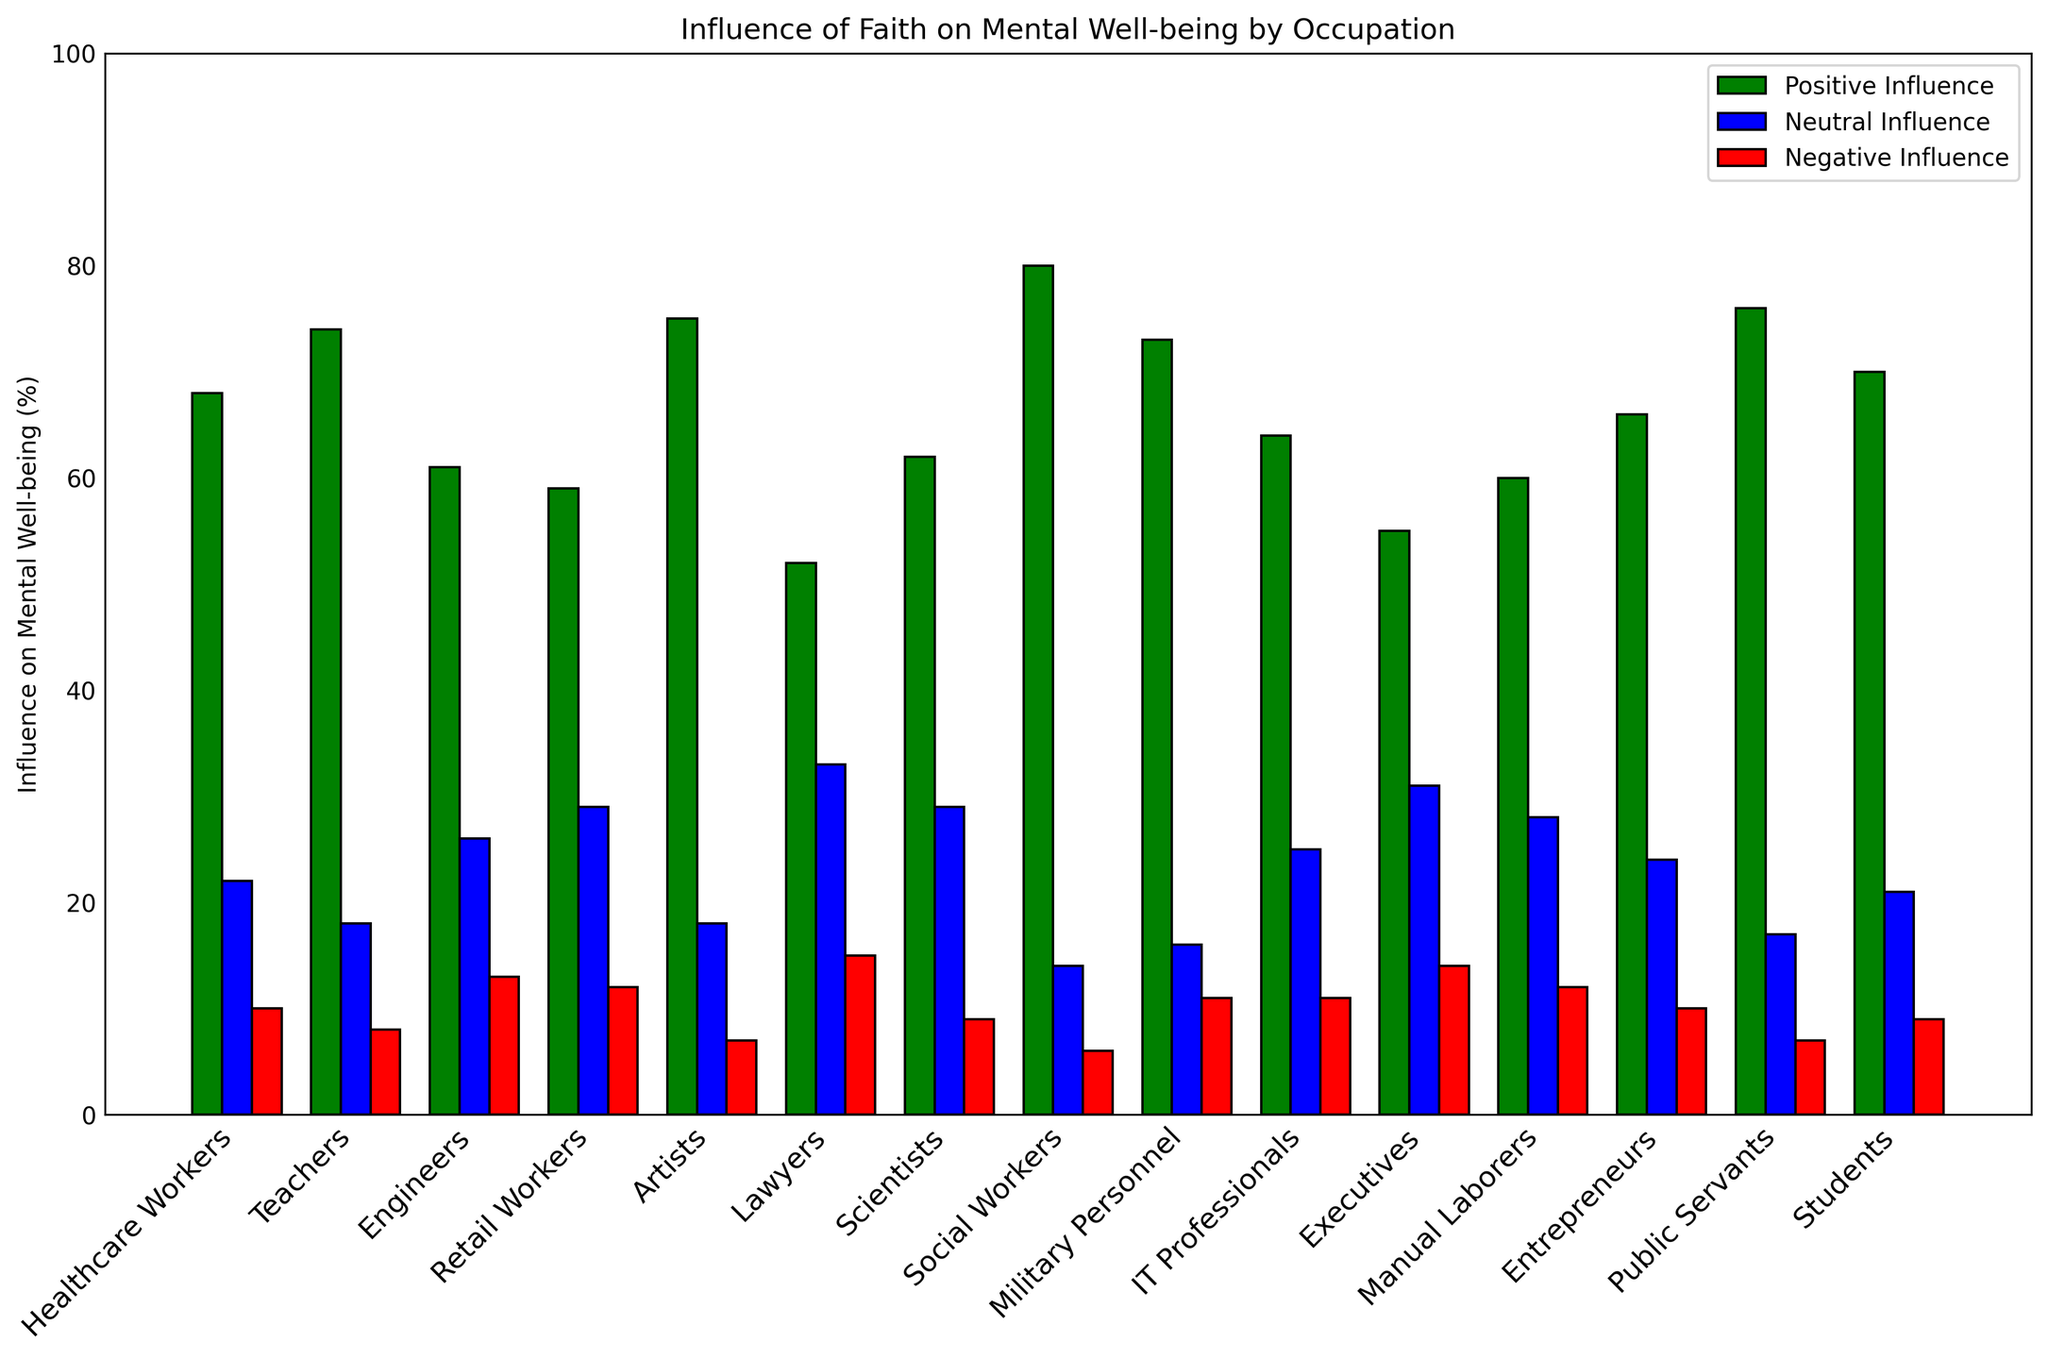What occupation reports the highest percentage of positive influence on mental well-being from faith? Identify the bar with the greatest height among the green bars. Social Workers have the highest percentage at 80%.
Answer: Social Workers Which occupation has the lowest reported negative influence on mental well-being from faith? Look for the shortest red bar. Social Workers and Public Servants both have the lowest value of 6%.
Answer: Social Workers, Public Servants Compare positive and negative influence on mental well-being for Engineers. Which is higher, and by how much? Find the heights of the green and red bars for Engineers. Positive influence (61%) is higher than negative influence (13%), so 61 - 13 = 48.
Answer: Positive by 48% What is the average positive influence on mental well-being across all occupations? Sum the green bars' values and divide by the number of occupations: (68 + 74 + 61 + 59 + 75 + 52 + 62 + 80 + 73 + 64 + 55 + 60 + 66 + 76 + 70) / 15 = 67.1.
Answer: 67.1% Which three occupations have the highest neutral influence on mental well-being from faith? Identify the three highest blue bars, which are Lawyers (33%), Retail Workers (29%), and Scientists (29%).
Answer: Lawyers, Retail Workers, Scientists What is the combined negative influence on mental well-being for Healthcare Workers and IT Professionals? Add the heights of the red bars for both occupations. Healthcare Workers (10%) + IT Professionals (11%) = 21%.
Answer: 21% What is the difference in positive influence between Artists and Lawyers? Subtract the shorter green bar from the taller one. Artists (75%) - Lawyers (52%) = 23%.
Answer: 23% Which occupation has more variance between positive and negative influences, and what is that variance? Calculate the difference for each occupation and identify the largest. Social Workers have the greatest variance: Positive (80%) - Negative (6%) = 74%.
Answer: Social Workers, 74% Compare the neutral influences between Entrepreneurs and Executives. Which is higher, and by how much? Find and compare the blue bars' values. Executives (31%) have a higher neutral influence than Entrepreneurs (24%), so 31 - 24 = 7.
Answer: Executives by 7% What is the ratio of positive to negative influence on mental well-being for Military Personnel? Divide the green bar by the red bar for Military Personnel. Positive (73%) / Negative (11%) = 6.636.
Answer: Approximately 6.64 